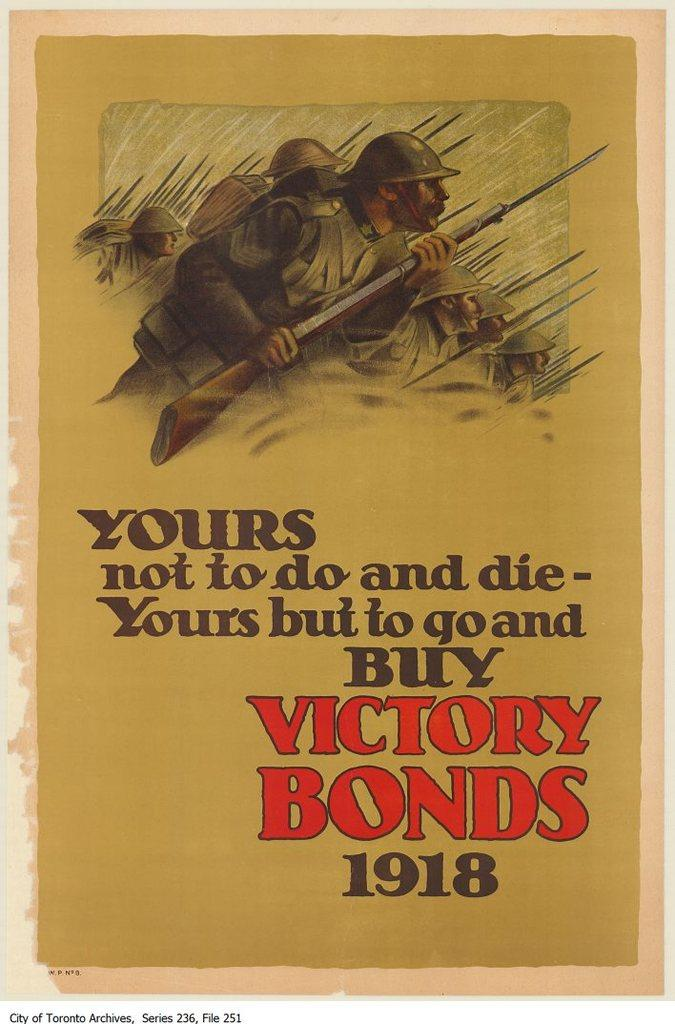<image>
Give a short and clear explanation of the subsequent image. The poster suggests that in 1918, one should buy bonds. 